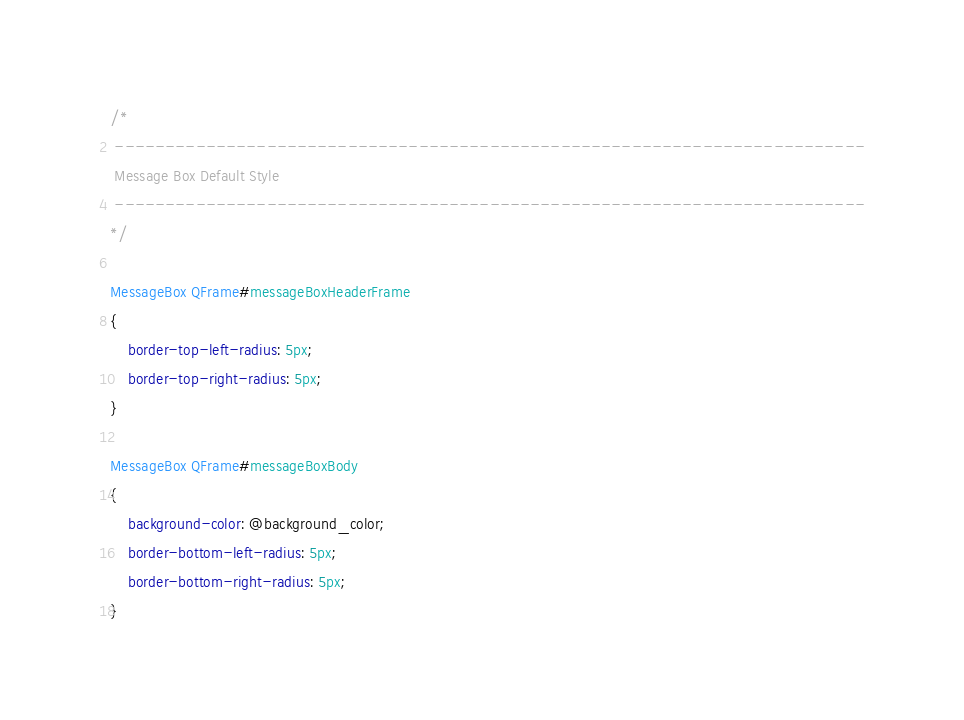<code> <loc_0><loc_0><loc_500><loc_500><_CSS_>/*
 --------------------------------------------------------------------------
 Message Box Default Style
 --------------------------------------------------------------------------
*/

MessageBox QFrame#messageBoxHeaderFrame
{
    border-top-left-radius: 5px;
    border-top-right-radius: 5px;
}

MessageBox QFrame#messageBoxBody
{
    background-color: @background_color;
    border-bottom-left-radius: 5px;
    border-bottom-right-radius: 5px;
}</code> 